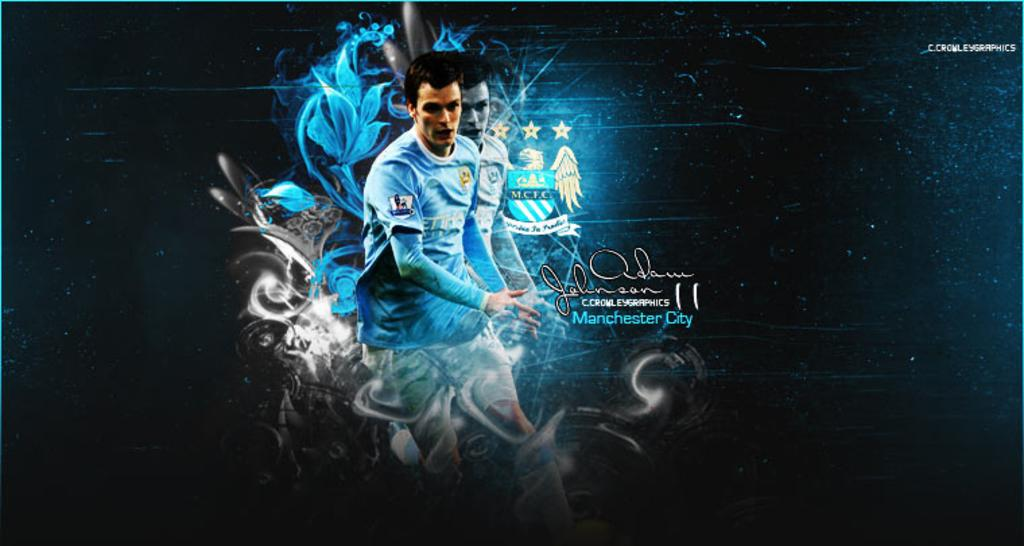<image>
Write a terse but informative summary of the picture. A poster showing a soccer player in a blue jersey and text that says Manchester City. 